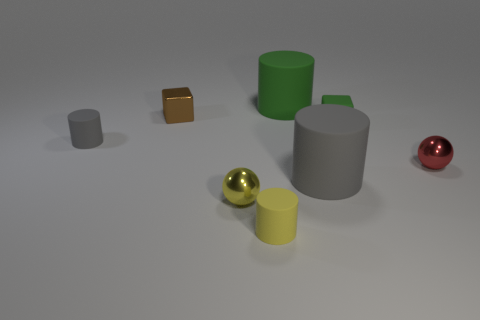There is a big cylinder that is behind the big gray thing; does it have the same color as the tiny cube to the right of the yellow rubber cylinder?
Keep it short and to the point. Yes. There is a rubber object that is the same color as the rubber cube; what is its size?
Offer a very short reply. Large. Are there any large objects of the same color as the tiny matte block?
Your response must be concise. Yes. What number of brown objects are small shiny spheres or small metal objects?
Your answer should be very brief. 1. What size is the rubber cylinder that is both on the right side of the small yellow rubber thing and in front of the tiny brown object?
Make the answer very short. Large. Is the number of small brown metal things left of the yellow rubber thing greater than the number of cyan rubber things?
Give a very brief answer. Yes. How many spheres are either blue metal objects or gray objects?
Your answer should be very brief. 0. There is a tiny matte object that is on the left side of the big gray rubber thing and behind the small red metallic sphere; what is its shape?
Make the answer very short. Cylinder. Are there the same number of matte cylinders that are behind the large green rubber thing and big rubber cylinders that are in front of the small green cube?
Ensure brevity in your answer.  No. How many things are red metallic spheres or brown matte cubes?
Make the answer very short. 1. 